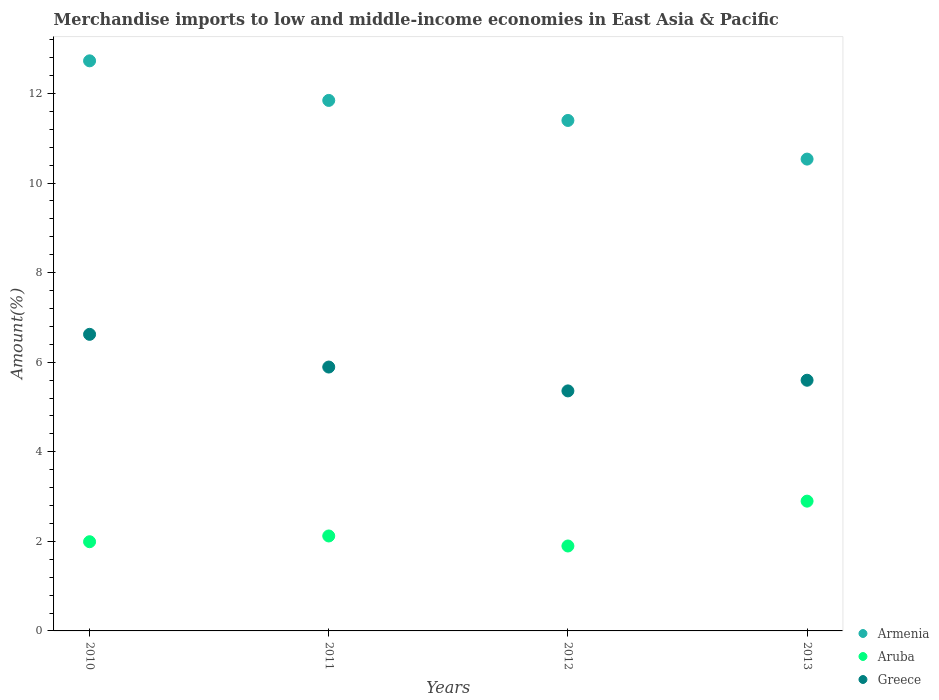Is the number of dotlines equal to the number of legend labels?
Keep it short and to the point. Yes. What is the percentage of amount earned from merchandise imports in Armenia in 2010?
Give a very brief answer. 12.73. Across all years, what is the maximum percentage of amount earned from merchandise imports in Greece?
Offer a very short reply. 6.62. Across all years, what is the minimum percentage of amount earned from merchandise imports in Aruba?
Make the answer very short. 1.9. In which year was the percentage of amount earned from merchandise imports in Armenia maximum?
Your response must be concise. 2010. In which year was the percentage of amount earned from merchandise imports in Armenia minimum?
Make the answer very short. 2013. What is the total percentage of amount earned from merchandise imports in Armenia in the graph?
Your response must be concise. 46.51. What is the difference between the percentage of amount earned from merchandise imports in Aruba in 2011 and that in 2013?
Give a very brief answer. -0.78. What is the difference between the percentage of amount earned from merchandise imports in Greece in 2013 and the percentage of amount earned from merchandise imports in Armenia in 2010?
Ensure brevity in your answer.  -7.13. What is the average percentage of amount earned from merchandise imports in Greece per year?
Your answer should be compact. 5.87. In the year 2013, what is the difference between the percentage of amount earned from merchandise imports in Aruba and percentage of amount earned from merchandise imports in Armenia?
Provide a short and direct response. -7.64. What is the ratio of the percentage of amount earned from merchandise imports in Armenia in 2011 to that in 2012?
Your response must be concise. 1.04. Is the difference between the percentage of amount earned from merchandise imports in Aruba in 2010 and 2013 greater than the difference between the percentage of amount earned from merchandise imports in Armenia in 2010 and 2013?
Provide a succinct answer. No. What is the difference between the highest and the second highest percentage of amount earned from merchandise imports in Greece?
Offer a terse response. 0.73. What is the difference between the highest and the lowest percentage of amount earned from merchandise imports in Greece?
Offer a very short reply. 1.26. In how many years, is the percentage of amount earned from merchandise imports in Aruba greater than the average percentage of amount earned from merchandise imports in Aruba taken over all years?
Your response must be concise. 1. Is the sum of the percentage of amount earned from merchandise imports in Aruba in 2011 and 2012 greater than the maximum percentage of amount earned from merchandise imports in Armenia across all years?
Offer a terse response. No. Does the percentage of amount earned from merchandise imports in Aruba monotonically increase over the years?
Make the answer very short. No. Is the percentage of amount earned from merchandise imports in Aruba strictly less than the percentage of amount earned from merchandise imports in Armenia over the years?
Ensure brevity in your answer.  Yes. What is the difference between two consecutive major ticks on the Y-axis?
Offer a terse response. 2. Does the graph contain grids?
Your response must be concise. No. Where does the legend appear in the graph?
Provide a short and direct response. Bottom right. How many legend labels are there?
Ensure brevity in your answer.  3. How are the legend labels stacked?
Keep it short and to the point. Vertical. What is the title of the graph?
Offer a very short reply. Merchandise imports to low and middle-income economies in East Asia & Pacific. Does "China" appear as one of the legend labels in the graph?
Offer a terse response. No. What is the label or title of the Y-axis?
Ensure brevity in your answer.  Amount(%). What is the Amount(%) of Armenia in 2010?
Provide a short and direct response. 12.73. What is the Amount(%) of Aruba in 2010?
Offer a very short reply. 1.99. What is the Amount(%) of Greece in 2010?
Give a very brief answer. 6.62. What is the Amount(%) in Armenia in 2011?
Make the answer very short. 11.85. What is the Amount(%) in Aruba in 2011?
Provide a succinct answer. 2.12. What is the Amount(%) in Greece in 2011?
Provide a short and direct response. 5.89. What is the Amount(%) of Armenia in 2012?
Keep it short and to the point. 11.4. What is the Amount(%) of Aruba in 2012?
Your answer should be very brief. 1.9. What is the Amount(%) of Greece in 2012?
Offer a terse response. 5.36. What is the Amount(%) of Armenia in 2013?
Ensure brevity in your answer.  10.54. What is the Amount(%) in Aruba in 2013?
Your answer should be very brief. 2.9. What is the Amount(%) of Greece in 2013?
Ensure brevity in your answer.  5.6. Across all years, what is the maximum Amount(%) of Armenia?
Give a very brief answer. 12.73. Across all years, what is the maximum Amount(%) in Aruba?
Provide a short and direct response. 2.9. Across all years, what is the maximum Amount(%) in Greece?
Provide a succinct answer. 6.62. Across all years, what is the minimum Amount(%) in Armenia?
Provide a short and direct response. 10.54. Across all years, what is the minimum Amount(%) in Aruba?
Offer a very short reply. 1.9. Across all years, what is the minimum Amount(%) of Greece?
Offer a terse response. 5.36. What is the total Amount(%) of Armenia in the graph?
Your response must be concise. 46.51. What is the total Amount(%) of Aruba in the graph?
Offer a terse response. 8.91. What is the total Amount(%) in Greece in the graph?
Provide a short and direct response. 23.47. What is the difference between the Amount(%) of Armenia in 2010 and that in 2011?
Make the answer very short. 0.88. What is the difference between the Amount(%) in Aruba in 2010 and that in 2011?
Provide a short and direct response. -0.13. What is the difference between the Amount(%) of Greece in 2010 and that in 2011?
Offer a very short reply. 0.73. What is the difference between the Amount(%) in Armenia in 2010 and that in 2012?
Your response must be concise. 1.33. What is the difference between the Amount(%) in Aruba in 2010 and that in 2012?
Your response must be concise. 0.1. What is the difference between the Amount(%) in Greece in 2010 and that in 2012?
Provide a succinct answer. 1.26. What is the difference between the Amount(%) of Armenia in 2010 and that in 2013?
Your response must be concise. 2.19. What is the difference between the Amount(%) of Aruba in 2010 and that in 2013?
Your answer should be very brief. -0.91. What is the difference between the Amount(%) in Greece in 2010 and that in 2013?
Your response must be concise. 1.02. What is the difference between the Amount(%) of Armenia in 2011 and that in 2012?
Your answer should be compact. 0.45. What is the difference between the Amount(%) in Aruba in 2011 and that in 2012?
Offer a very short reply. 0.22. What is the difference between the Amount(%) in Greece in 2011 and that in 2012?
Your response must be concise. 0.53. What is the difference between the Amount(%) in Armenia in 2011 and that in 2013?
Provide a short and direct response. 1.31. What is the difference between the Amount(%) of Aruba in 2011 and that in 2013?
Ensure brevity in your answer.  -0.78. What is the difference between the Amount(%) in Greece in 2011 and that in 2013?
Make the answer very short. 0.29. What is the difference between the Amount(%) in Armenia in 2012 and that in 2013?
Make the answer very short. 0.86. What is the difference between the Amount(%) of Aruba in 2012 and that in 2013?
Provide a short and direct response. -1. What is the difference between the Amount(%) of Greece in 2012 and that in 2013?
Provide a succinct answer. -0.24. What is the difference between the Amount(%) in Armenia in 2010 and the Amount(%) in Aruba in 2011?
Offer a terse response. 10.61. What is the difference between the Amount(%) in Armenia in 2010 and the Amount(%) in Greece in 2011?
Give a very brief answer. 6.84. What is the difference between the Amount(%) of Aruba in 2010 and the Amount(%) of Greece in 2011?
Ensure brevity in your answer.  -3.9. What is the difference between the Amount(%) in Armenia in 2010 and the Amount(%) in Aruba in 2012?
Offer a terse response. 10.83. What is the difference between the Amount(%) of Armenia in 2010 and the Amount(%) of Greece in 2012?
Offer a terse response. 7.37. What is the difference between the Amount(%) of Aruba in 2010 and the Amount(%) of Greece in 2012?
Provide a succinct answer. -3.37. What is the difference between the Amount(%) in Armenia in 2010 and the Amount(%) in Aruba in 2013?
Your response must be concise. 9.83. What is the difference between the Amount(%) of Armenia in 2010 and the Amount(%) of Greece in 2013?
Offer a very short reply. 7.13. What is the difference between the Amount(%) of Aruba in 2010 and the Amount(%) of Greece in 2013?
Your response must be concise. -3.61. What is the difference between the Amount(%) of Armenia in 2011 and the Amount(%) of Aruba in 2012?
Make the answer very short. 9.95. What is the difference between the Amount(%) in Armenia in 2011 and the Amount(%) in Greece in 2012?
Your response must be concise. 6.49. What is the difference between the Amount(%) of Aruba in 2011 and the Amount(%) of Greece in 2012?
Your response must be concise. -3.24. What is the difference between the Amount(%) in Armenia in 2011 and the Amount(%) in Aruba in 2013?
Your answer should be compact. 8.95. What is the difference between the Amount(%) of Armenia in 2011 and the Amount(%) of Greece in 2013?
Provide a succinct answer. 6.25. What is the difference between the Amount(%) in Aruba in 2011 and the Amount(%) in Greece in 2013?
Your response must be concise. -3.48. What is the difference between the Amount(%) of Armenia in 2012 and the Amount(%) of Aruba in 2013?
Offer a terse response. 8.5. What is the difference between the Amount(%) of Armenia in 2012 and the Amount(%) of Greece in 2013?
Your answer should be compact. 5.8. What is the difference between the Amount(%) in Aruba in 2012 and the Amount(%) in Greece in 2013?
Your answer should be very brief. -3.7. What is the average Amount(%) in Armenia per year?
Your answer should be very brief. 11.63. What is the average Amount(%) of Aruba per year?
Keep it short and to the point. 2.23. What is the average Amount(%) of Greece per year?
Your answer should be very brief. 5.87. In the year 2010, what is the difference between the Amount(%) in Armenia and Amount(%) in Aruba?
Give a very brief answer. 10.74. In the year 2010, what is the difference between the Amount(%) of Armenia and Amount(%) of Greece?
Your response must be concise. 6.11. In the year 2010, what is the difference between the Amount(%) of Aruba and Amount(%) of Greece?
Ensure brevity in your answer.  -4.63. In the year 2011, what is the difference between the Amount(%) in Armenia and Amount(%) in Aruba?
Your answer should be compact. 9.73. In the year 2011, what is the difference between the Amount(%) of Armenia and Amount(%) of Greece?
Keep it short and to the point. 5.95. In the year 2011, what is the difference between the Amount(%) of Aruba and Amount(%) of Greece?
Offer a terse response. -3.77. In the year 2012, what is the difference between the Amount(%) of Armenia and Amount(%) of Aruba?
Give a very brief answer. 9.5. In the year 2012, what is the difference between the Amount(%) of Armenia and Amount(%) of Greece?
Your answer should be very brief. 6.04. In the year 2012, what is the difference between the Amount(%) of Aruba and Amount(%) of Greece?
Ensure brevity in your answer.  -3.46. In the year 2013, what is the difference between the Amount(%) of Armenia and Amount(%) of Aruba?
Keep it short and to the point. 7.64. In the year 2013, what is the difference between the Amount(%) in Armenia and Amount(%) in Greece?
Provide a succinct answer. 4.94. In the year 2013, what is the difference between the Amount(%) of Aruba and Amount(%) of Greece?
Give a very brief answer. -2.7. What is the ratio of the Amount(%) in Armenia in 2010 to that in 2011?
Your answer should be compact. 1.07. What is the ratio of the Amount(%) of Aruba in 2010 to that in 2011?
Provide a short and direct response. 0.94. What is the ratio of the Amount(%) of Greece in 2010 to that in 2011?
Provide a succinct answer. 1.12. What is the ratio of the Amount(%) of Armenia in 2010 to that in 2012?
Your answer should be compact. 1.12. What is the ratio of the Amount(%) of Aruba in 2010 to that in 2012?
Provide a succinct answer. 1.05. What is the ratio of the Amount(%) of Greece in 2010 to that in 2012?
Your response must be concise. 1.24. What is the ratio of the Amount(%) in Armenia in 2010 to that in 2013?
Your answer should be compact. 1.21. What is the ratio of the Amount(%) of Aruba in 2010 to that in 2013?
Provide a short and direct response. 0.69. What is the ratio of the Amount(%) in Greece in 2010 to that in 2013?
Make the answer very short. 1.18. What is the ratio of the Amount(%) in Armenia in 2011 to that in 2012?
Offer a very short reply. 1.04. What is the ratio of the Amount(%) in Aruba in 2011 to that in 2012?
Your answer should be compact. 1.12. What is the ratio of the Amount(%) in Greece in 2011 to that in 2012?
Your answer should be compact. 1.1. What is the ratio of the Amount(%) in Armenia in 2011 to that in 2013?
Offer a very short reply. 1.12. What is the ratio of the Amount(%) in Aruba in 2011 to that in 2013?
Your answer should be compact. 0.73. What is the ratio of the Amount(%) of Greece in 2011 to that in 2013?
Your answer should be compact. 1.05. What is the ratio of the Amount(%) of Armenia in 2012 to that in 2013?
Your answer should be compact. 1.08. What is the ratio of the Amount(%) in Aruba in 2012 to that in 2013?
Your answer should be compact. 0.65. What is the ratio of the Amount(%) of Greece in 2012 to that in 2013?
Make the answer very short. 0.96. What is the difference between the highest and the second highest Amount(%) of Armenia?
Provide a short and direct response. 0.88. What is the difference between the highest and the second highest Amount(%) of Aruba?
Your response must be concise. 0.78. What is the difference between the highest and the second highest Amount(%) in Greece?
Keep it short and to the point. 0.73. What is the difference between the highest and the lowest Amount(%) in Armenia?
Offer a terse response. 2.19. What is the difference between the highest and the lowest Amount(%) of Aruba?
Your answer should be compact. 1. What is the difference between the highest and the lowest Amount(%) in Greece?
Offer a very short reply. 1.26. 